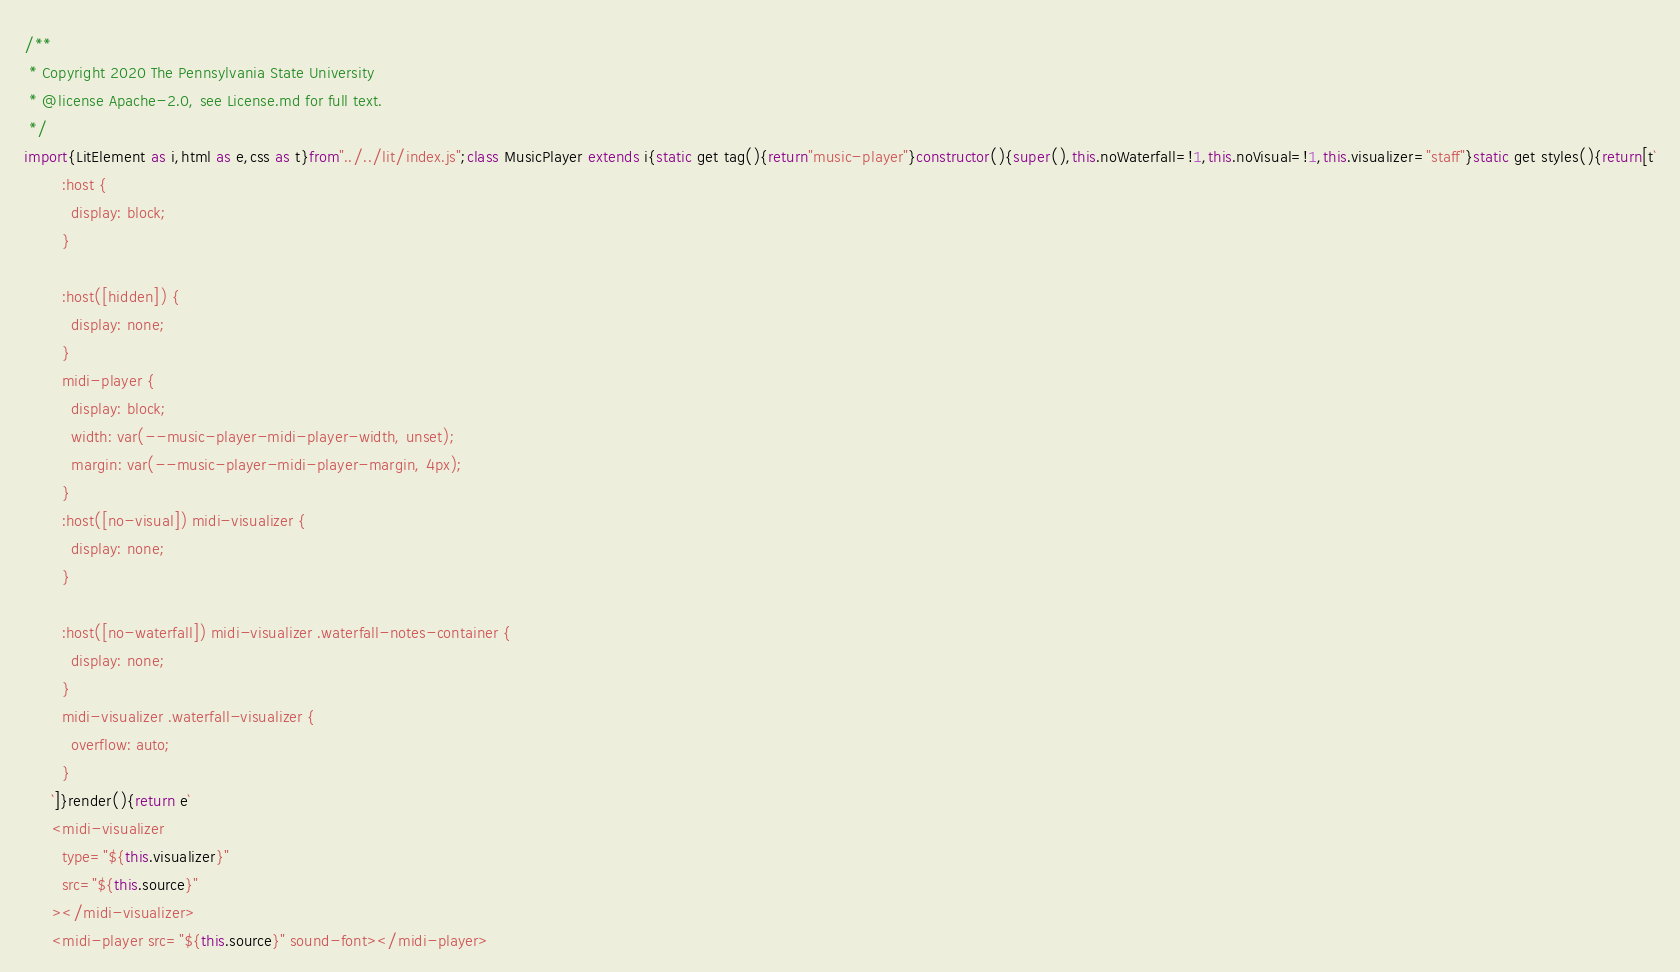Convert code to text. <code><loc_0><loc_0><loc_500><loc_500><_JavaScript_>/**
 * Copyright 2020 The Pennsylvania State University
 * @license Apache-2.0, see License.md for full text.
 */
import{LitElement as i,html as e,css as t}from"../../lit/index.js";class MusicPlayer extends i{static get tag(){return"music-player"}constructor(){super(),this.noWaterfall=!1,this.noVisual=!1,this.visualizer="staff"}static get styles(){return[t`
        :host {
          display: block;
        }

        :host([hidden]) {
          display: none;
        }
        midi-player {
          display: block;
          width: var(--music-player-midi-player-width, unset);
          margin: var(--music-player-midi-player-margin, 4px);
        }
        :host([no-visual]) midi-visualizer {
          display: none;
        }

        :host([no-waterfall]) midi-visualizer .waterfall-notes-container {
          display: none;
        }
        midi-visualizer .waterfall-visualizer {
          overflow: auto;
        }
      `]}render(){return e`
      <midi-visualizer
        type="${this.visualizer}"
        src="${this.source}"
      ></midi-visualizer>
      <midi-player src="${this.source}" sound-font></midi-player></code> 